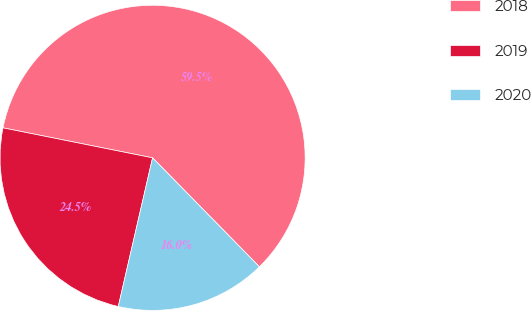<chart> <loc_0><loc_0><loc_500><loc_500><pie_chart><fcel>2018<fcel>2019<fcel>2020<nl><fcel>59.51%<fcel>24.54%<fcel>15.95%<nl></chart> 